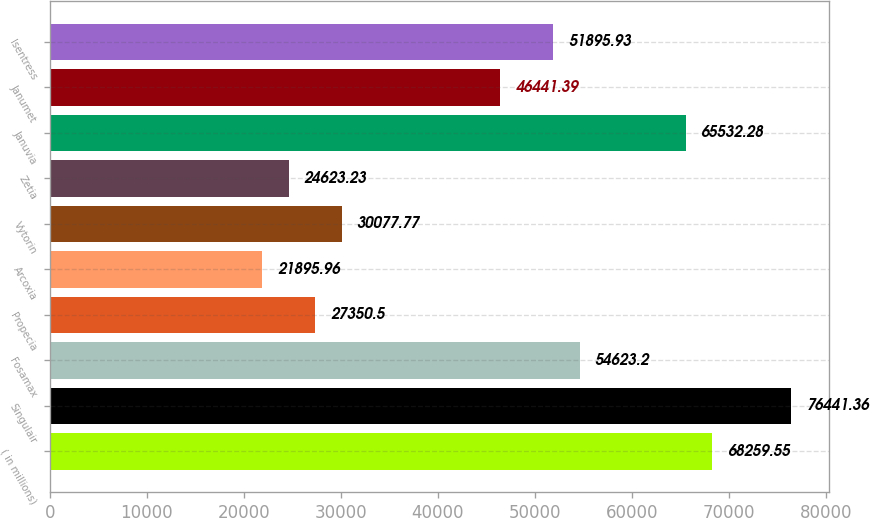Convert chart to OTSL. <chart><loc_0><loc_0><loc_500><loc_500><bar_chart><fcel>( in millions)<fcel>Singulair<fcel>Fosamax<fcel>Propecia<fcel>Arcoxia<fcel>Vytorin<fcel>Zetia<fcel>Januvia<fcel>Janumet<fcel>Isentress<nl><fcel>68259.6<fcel>76441.4<fcel>54623.2<fcel>27350.5<fcel>21896<fcel>30077.8<fcel>24623.2<fcel>65532.3<fcel>46441.4<fcel>51895.9<nl></chart> 